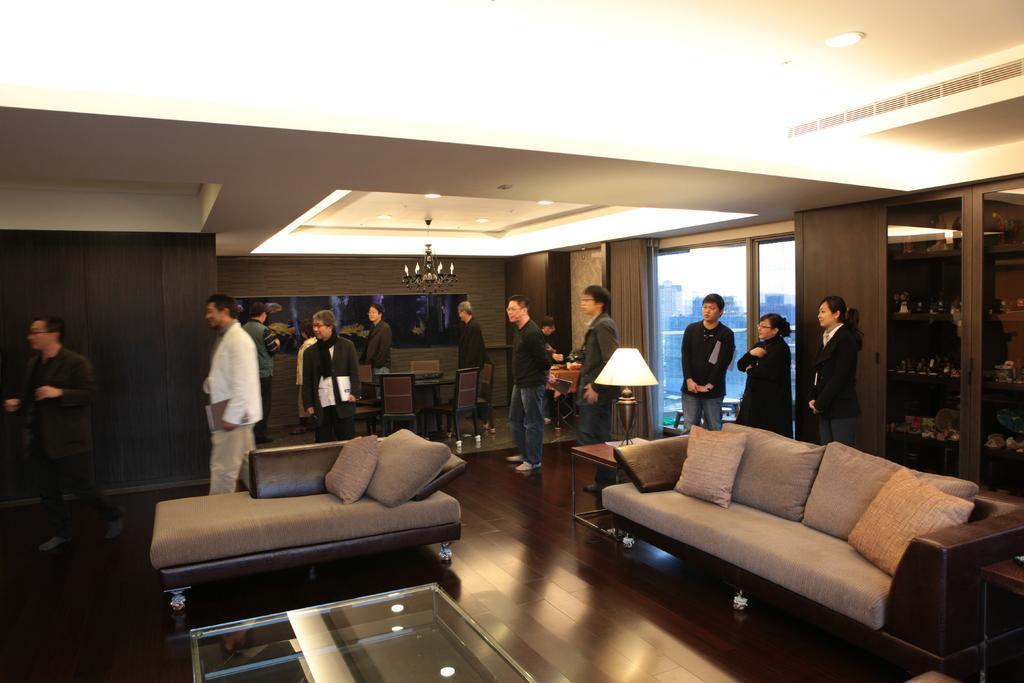How would you summarize this image in a sentence or two? In this image there is a floor at the bottom. There is a person and wooden object on the left corner. There is a window, there are people, it looks like a cupboard with objects on it in the right corner. There is a table, there are sofas, pillows, a table with a lamp on it in the foreground. There is a table, there are chairs, people, there is a wooden object in the background. There are lights on the roof at the top. 